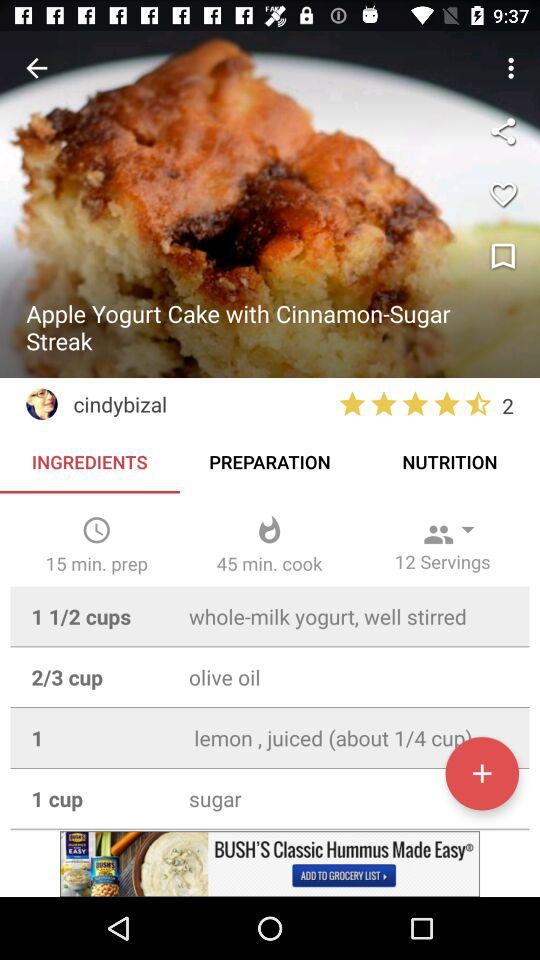How many minutes longer is the cook time than the prep time?
Answer the question using a single word or phrase. 30 